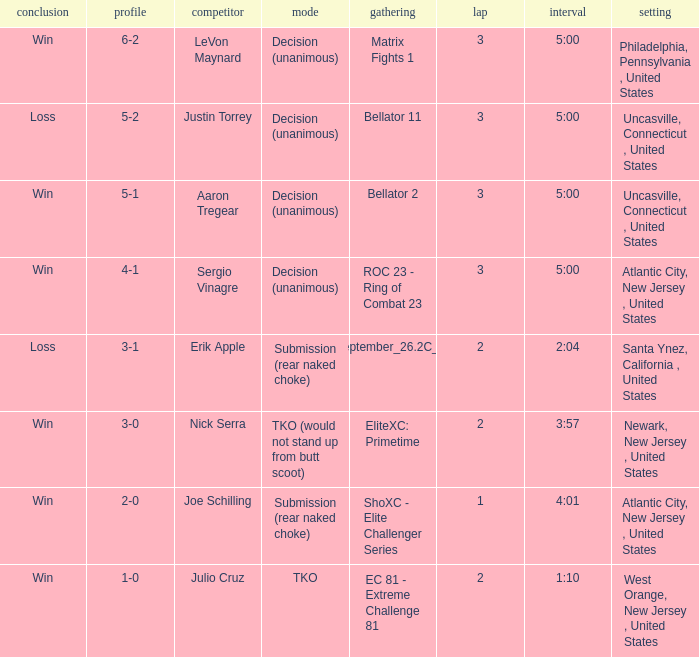What round was it when the method was TKO (would not stand up from Butt Scoot)? 2.0. 